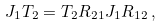Convert formula to latex. <formula><loc_0><loc_0><loc_500><loc_500>J _ { 1 } T _ { 2 } = T _ { 2 } R _ { 2 1 } J _ { 1 } R _ { 1 2 } \, ,</formula> 